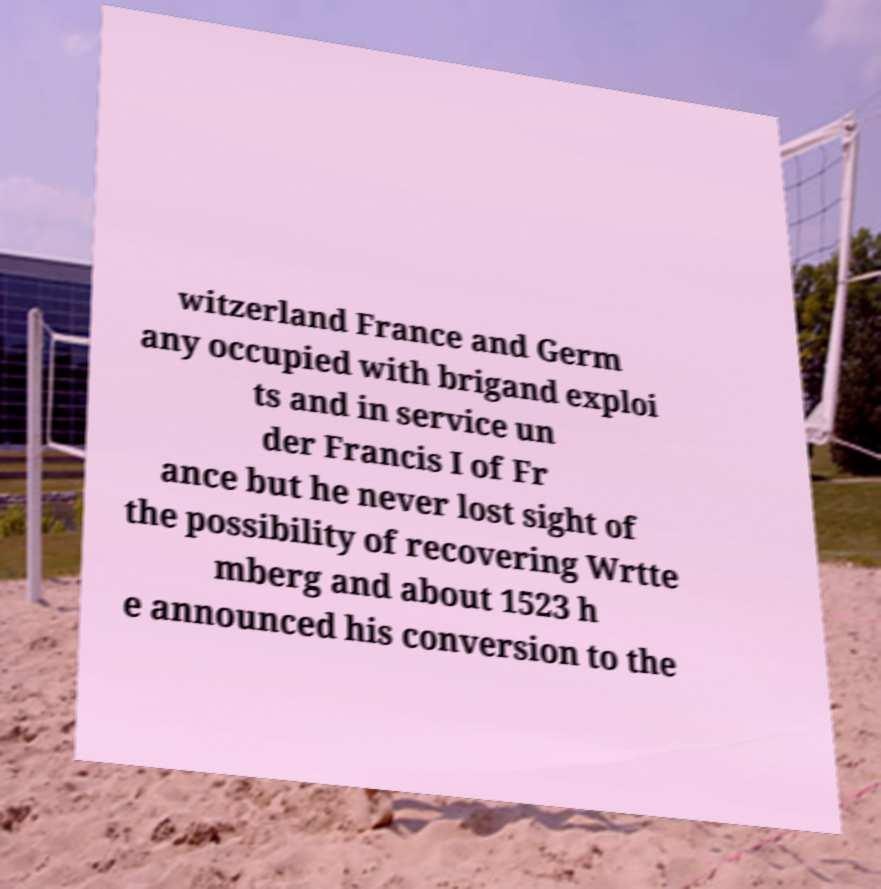Please identify and transcribe the text found in this image. witzerland France and Germ any occupied with brigand exploi ts and in service un der Francis I of Fr ance but he never lost sight of the possibility of recovering Wrtte mberg and about 1523 h e announced his conversion to the 